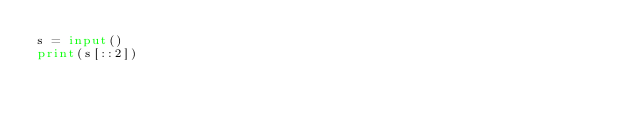<code> <loc_0><loc_0><loc_500><loc_500><_Python_>s = input()
print(s[::2])</code> 